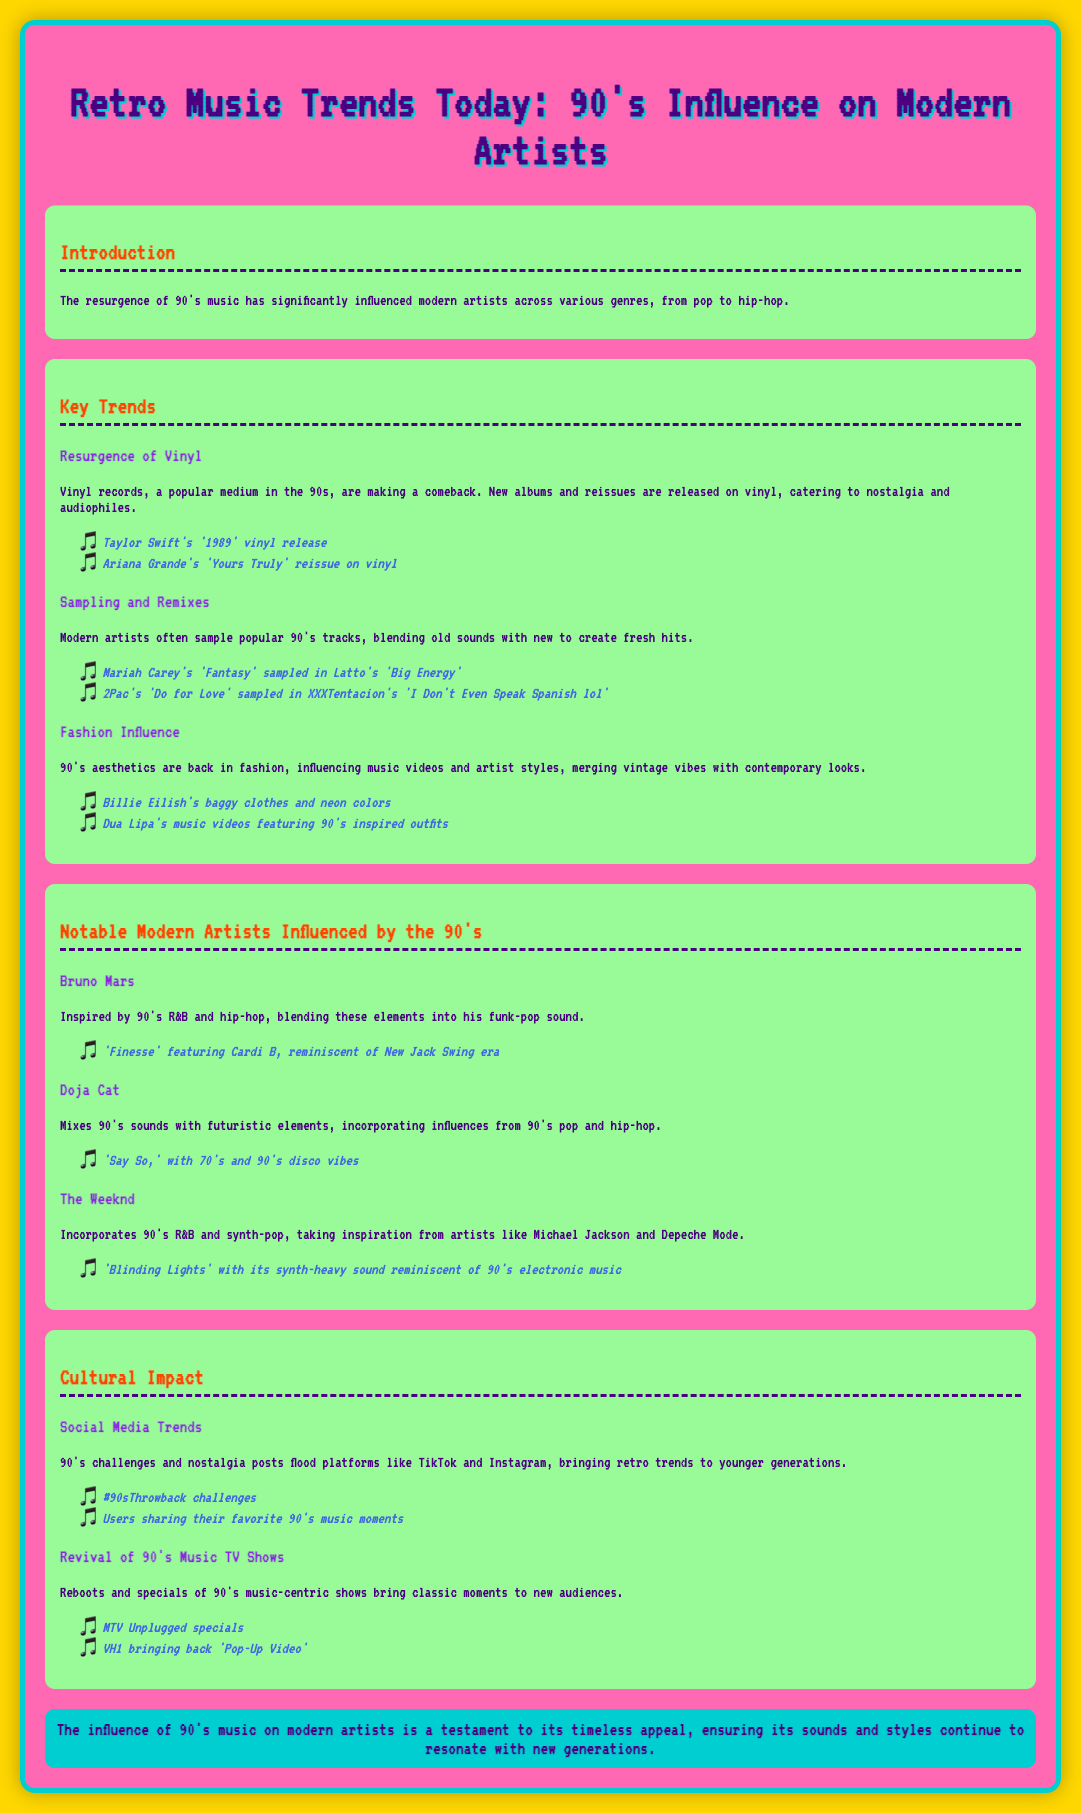What is the title of the document? The title of the document is prominently displayed at the top, indicating the main focus on retro music trends and the 90's influence.
Answer: Retro Music Trends Today: 90's Influence on Modern Artists Who is an example of a modern artist influenced by the 90's? The document lists several modern artists that are influenced by 90's music, one being Bruno Mars.
Answer: Bruno Mars What is one key trend mentioned regarding 90's music? The document highlights several trends, one being the resurgence of vinyl records that were popular in the 90's.
Answer: Resurgence of Vinyl Which artist's song features a sample from a 90's track? The document notes that Latto sampled Mariah Carey's 'Fantasy' in her song 'Big Energy.'
Answer: Latto What color is the background of the infographic? The background color of the entire document is specified in the styling section of the code as gold, creating a vibrant look.
Answer: Gold Name a fashion influence from the 90's in modern music. The document cites Billie Eilish's baggy clothes and neon colors as a reflection of 90's fashion influence.
Answer: Billie Eilish's baggy clothes and neon colors What type of social media trends are mentioned? The document discusses nostalgia posts and challenges related to 90's music on social media platforms like TikTok and Instagram.
Answer: #90sThrowback challenges What is the overall conclusion about 90's music influence? The conclusion summarizes the document's focus, stating that 90's music continues to resonate with new generations due to its timeless appeal.
Answer: Timeless appeal 